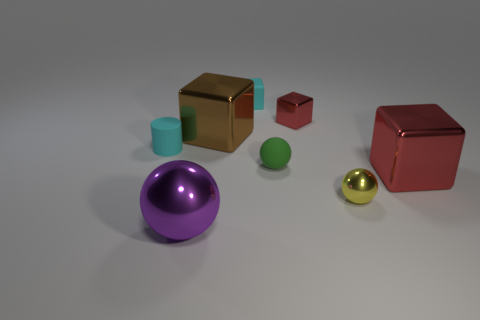Do the small green sphere and the cyan thing that is on the left side of the large ball have the same material?
Your answer should be compact. Yes. What is the material of the cylinder that is the same color as the matte block?
Offer a very short reply. Rubber. How many tiny metallic cubes are the same color as the small cylinder?
Give a very brief answer. 0. What is the size of the cyan rubber block?
Your answer should be very brief. Small. There is a large purple thing; is its shape the same as the cyan thing that is behind the tiny cyan cylinder?
Provide a short and direct response. No. The tiny cylinder that is the same material as the green sphere is what color?
Your answer should be very brief. Cyan. There is a red thing that is behind the big red thing; what size is it?
Ensure brevity in your answer.  Small. Are there fewer rubber things left of the large red metallic object than gray shiny cylinders?
Make the answer very short. No. Is the color of the small rubber cylinder the same as the tiny metal block?
Ensure brevity in your answer.  No. Is there any other thing that has the same shape as the big brown metallic thing?
Offer a very short reply. Yes. 